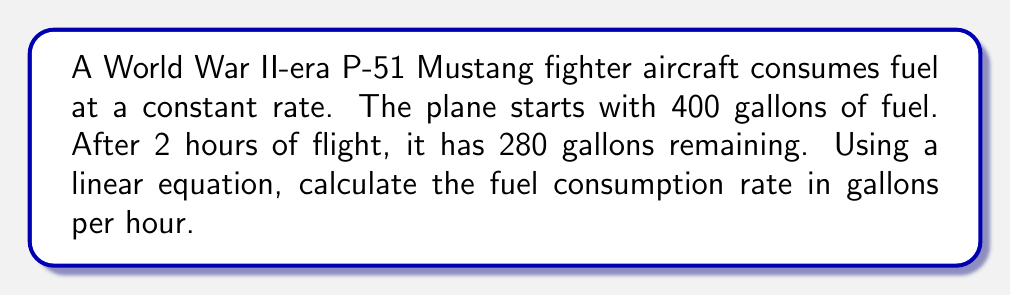Show me your answer to this math problem. Let's approach this step-by-step:

1) Let $x$ be the number of hours flown and $y$ be the amount of fuel remaining in gallons.

2) We can represent this situation with a linear equation in the form:
   $y = mx + b$
   where $m$ is the slope (fuel consumption rate) and $b$ is the y-intercept (initial fuel amount).

3) We know two points:
   $(0, 400)$ : At the start, 0 hours flown, 400 gallons remaining
   $(2, 280)$ : After 2 hours, 280 gallons remaining

4) We can find the slope (fuel consumption rate) using the slope formula:
   $m = \frac{y_2 - y_1}{x_2 - x_1} = \frac{280 - 400}{2 - 0} = \frac{-120}{2} = -60$

5) The negative sign indicates fuel is being consumed (decreasing over time).

6) Therefore, the fuel consumption rate is 60 gallons per hour.

7) We can verify this by plugging the points into the equation:
   $400 = -60(0) + b$, so $b = 400$ (initial fuel amount)
   $280 = -60(2) + 400$, which is true

8) The complete linear equation is:
   $y = -60x + 400$
Answer: 60 gallons per hour 